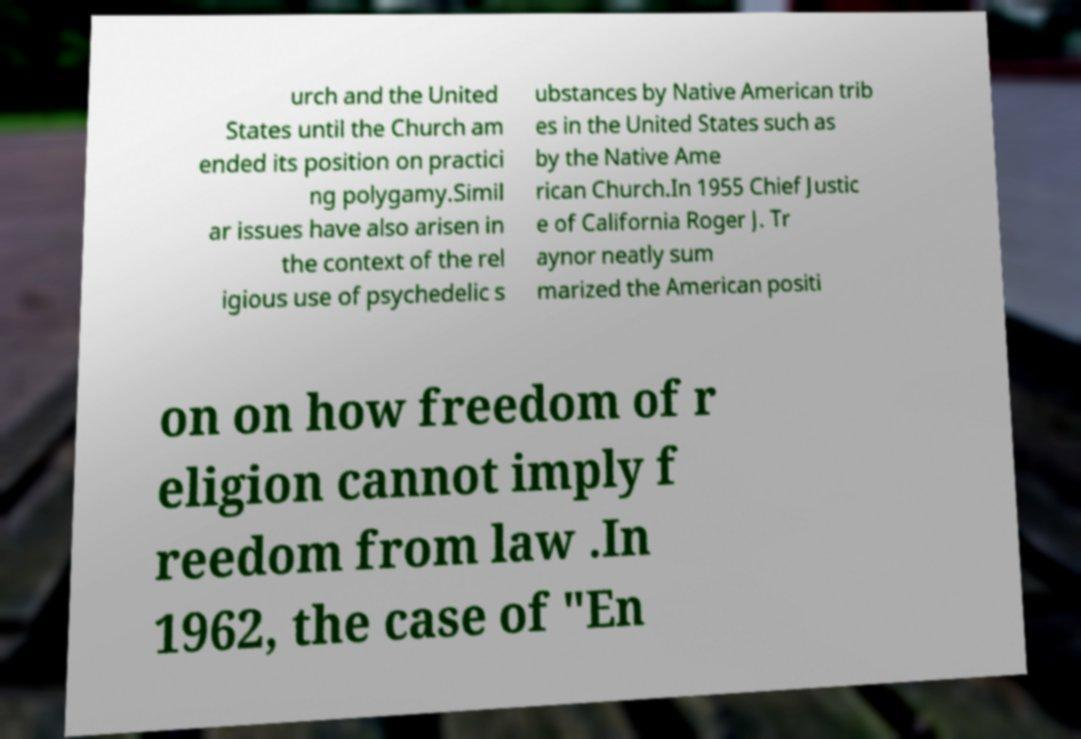Could you assist in decoding the text presented in this image and type it out clearly? urch and the United States until the Church am ended its position on practici ng polygamy.Simil ar issues have also arisen in the context of the rel igious use of psychedelic s ubstances by Native American trib es in the United States such as by the Native Ame rican Church.In 1955 Chief Justic e of California Roger J. Tr aynor neatly sum marized the American positi on on how freedom of r eligion cannot imply f reedom from law .In 1962, the case of "En 